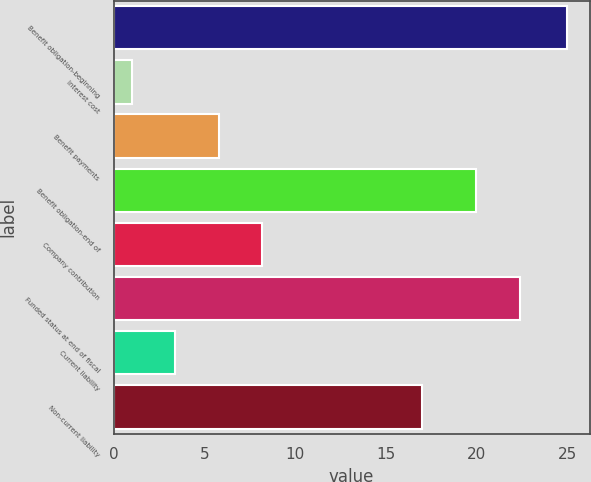Convert chart. <chart><loc_0><loc_0><loc_500><loc_500><bar_chart><fcel>Benefit obligation-beginning<fcel>Interest cost<fcel>Benefit payments<fcel>Benefit obligation-end of<fcel>Company contribution<fcel>Funded status at end of fiscal<fcel>Current liability<fcel>Non-current liability<nl><fcel>25<fcel>1<fcel>5.8<fcel>20<fcel>8.2<fcel>22.4<fcel>3.4<fcel>17<nl></chart> 